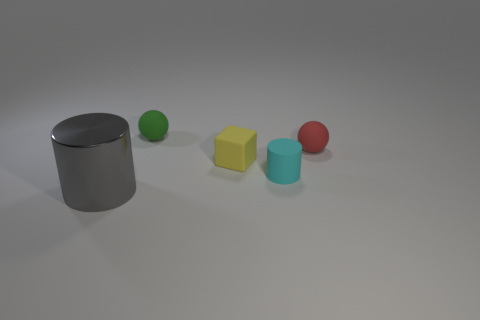How many red objects are either rubber blocks or tiny cylinders?
Your response must be concise. 0. There is a tiny ball behind the thing that is to the right of the tiny rubber cylinder; what is its color?
Provide a short and direct response. Green. What color is the cylinder that is behind the big metal cylinder?
Your answer should be very brief. Cyan. There is a rubber object on the left side of the rubber cube; does it have the same size as the large gray object?
Provide a succinct answer. No. Is there a gray metallic object of the same size as the cyan cylinder?
Keep it short and to the point. No. There is a tiny thing that is behind the small red rubber object; is its color the same as the cylinder on the left side of the matte cylinder?
Ensure brevity in your answer.  No. How many other things are there of the same shape as the small yellow thing?
Your response must be concise. 0. What shape is the thing that is behind the red sphere?
Keep it short and to the point. Sphere. There is a red object; does it have the same shape as the gray object left of the cyan cylinder?
Give a very brief answer. No. What size is the thing that is left of the block and in front of the small green rubber ball?
Make the answer very short. Large. 